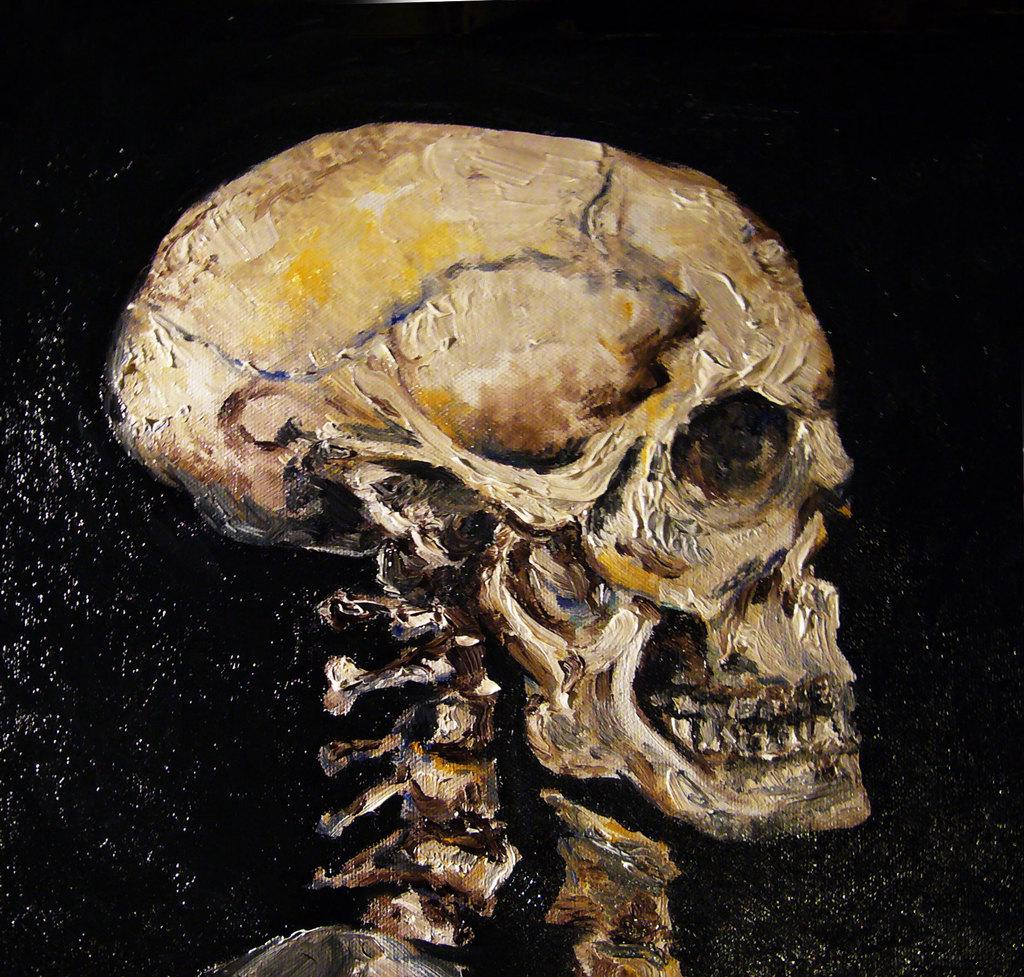What type of artwork is shown in the image? The image is a painting. What subject matter is depicted in the painting? The painting depicts a human skeleton. What color is the background of the painting? The background of the painting is black in color. How does the painting depict the effects of pollution on the human body? The painting does not depict the effects of pollution on the human body; it simply shows a human skeleton against a black background. 